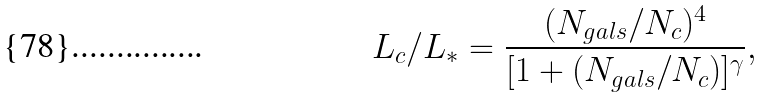<formula> <loc_0><loc_0><loc_500><loc_500>L _ { c } / L _ { * } = \frac { ( N _ { g a l s } / N _ { c } ) ^ { 4 } } { [ 1 + ( N _ { g a l s } / N _ { c } ) ] ^ { \gamma } } ,</formula> 